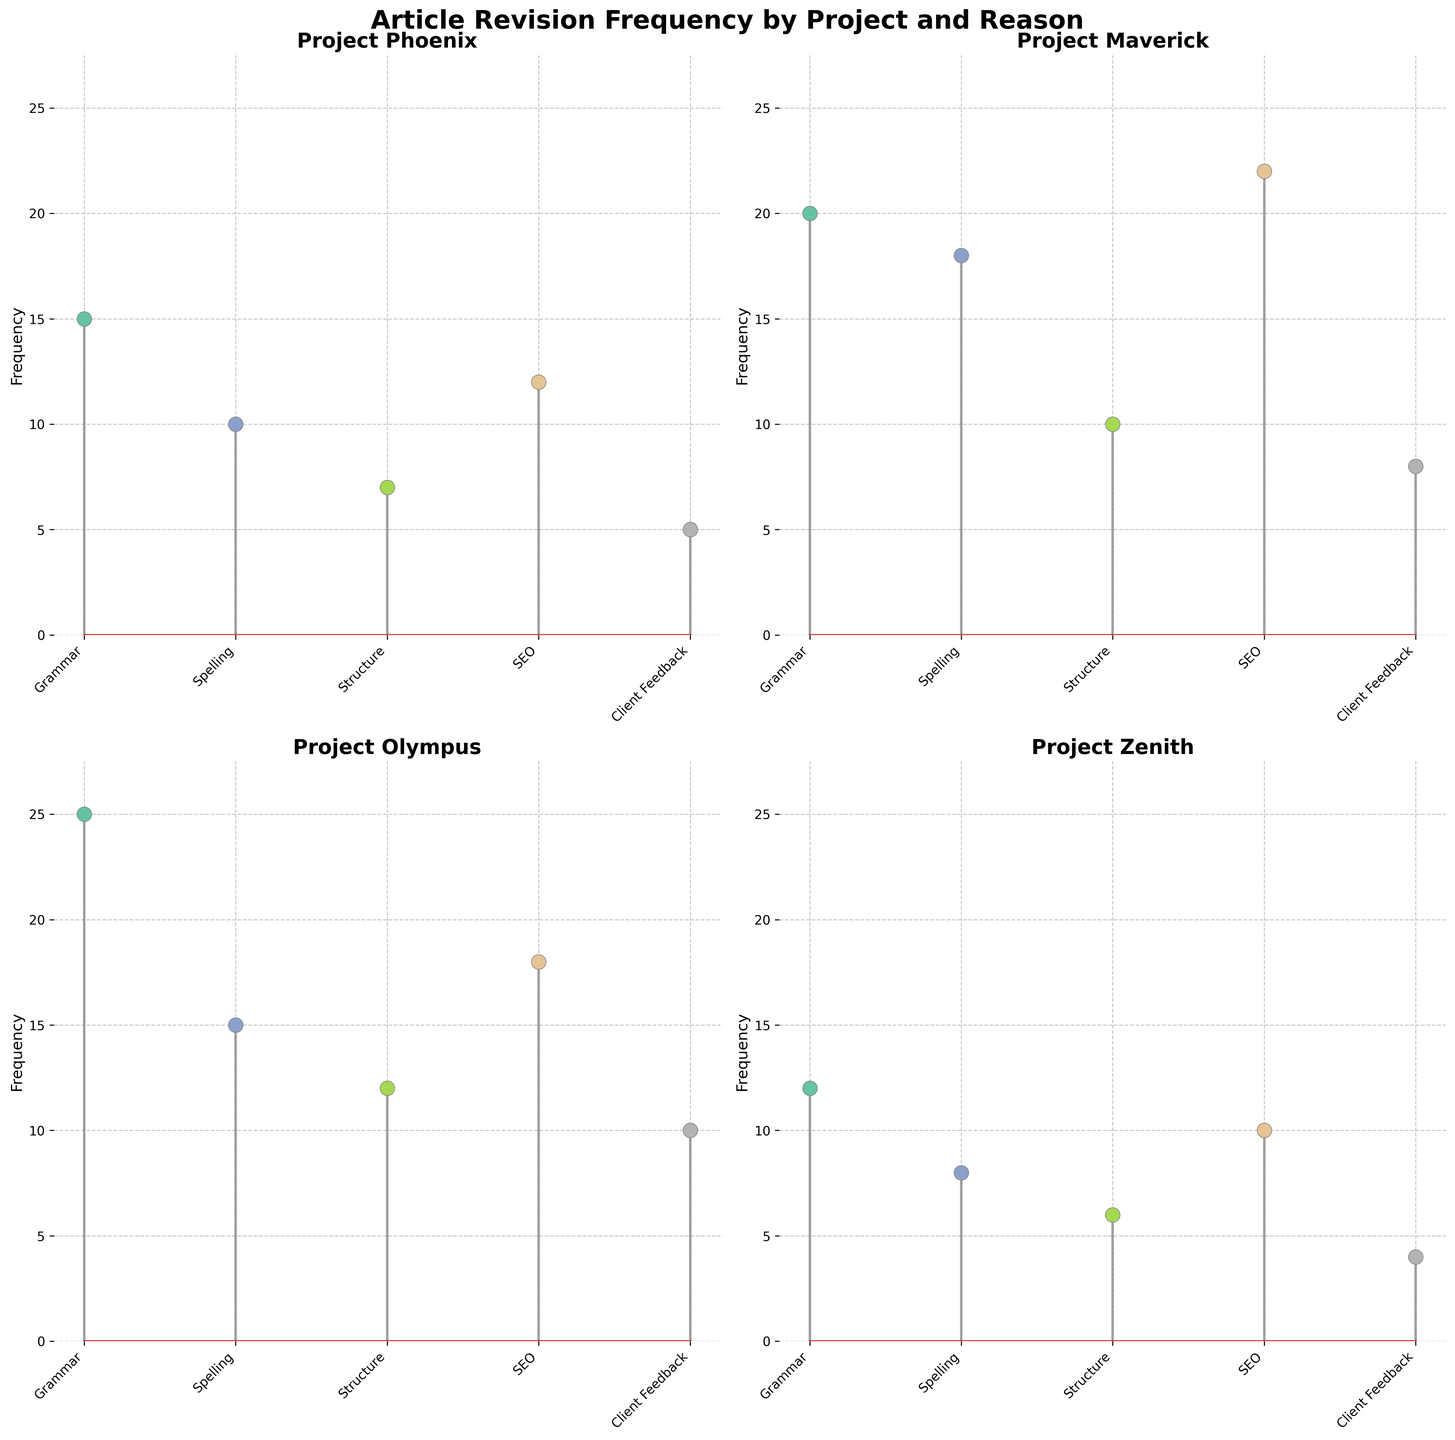What is the title of the figure? The title of the figure is written at the top center of the plot area. It states the overall topic of the figure.
Answer: Article Revision Frequency by Project and Reason Which project has the highest frequency for grammar revisions? Look at the stem plot of each project for the Grammar category and identify the maximum value among them.
Answer: Project Olympus What is the total frequency of SEO revisions across all projects? Sum the SEO values for all projects by observing the heights of the SEO stems in each subplot. SEO frequencies: 12 (Phoenix) + 22 (Maverick) + 18 (Olympus) + 10 (Zenith) = 62
Answer: 62 Compare the frequency of spelling revisions between Project Phoenix and Project Maverick. Which project has a higher frequency? Check the stem heights for the Spelling category in the subplots of both Project Phoenix and Project Maverick.
Answer: Project Maverick Which category has the lowest frequency in Project Zenith? Find the smallest stem height in the Project Zenith subplot.
Answer: Client Feedback What is the average frequency of structure revisions across all projects? Calculate the average by summing the Structure frequencies and dividing by the number of projects. Structure frequencies: 7 (Phoenix) + 10 (Maverick) + 12 (Olympus) + 6 (Zenith). Sum = 35. Average = 35/4 = 8.75
Answer: 8.75 How does the frequency of client feedback revisions in Project Olympus compare to Project Zenith? Compare the stem heights for the Client Feedback category between Project Olympus and Project Zenith.
Answer: Project Olympus is higher Which project has the most balanced frequencies across all revision reasons? Visually examine the subplots for each project and determine which one has the least variation in stem heights across all categories.
Answer: Project Zenith What is the difference in the highest frequency of revisions between Project Maverick and Project Phoenix? Identify the highest frequencies in the subplots of Project Maverick (SEO - 22) and Project Phoenix (Grammar - 15), then calculate the difference (22 - 15).
Answer: 7 In which project does SEO have a higher frequency than grammar? Compare the stem heights of SEO and Grammar categories for each project. Identify where SEO stem is higher than Grammar stem. For Phoenix (SEO - 12, Grammar - 15), Maverick (SEO - 22, Grammar - 20), Olympus (SEO - 18, Grammar - 25), and Zenith (SEO - 10, Grammar - 12), only Maverick fits this condition.
Answer: Project Maverick 